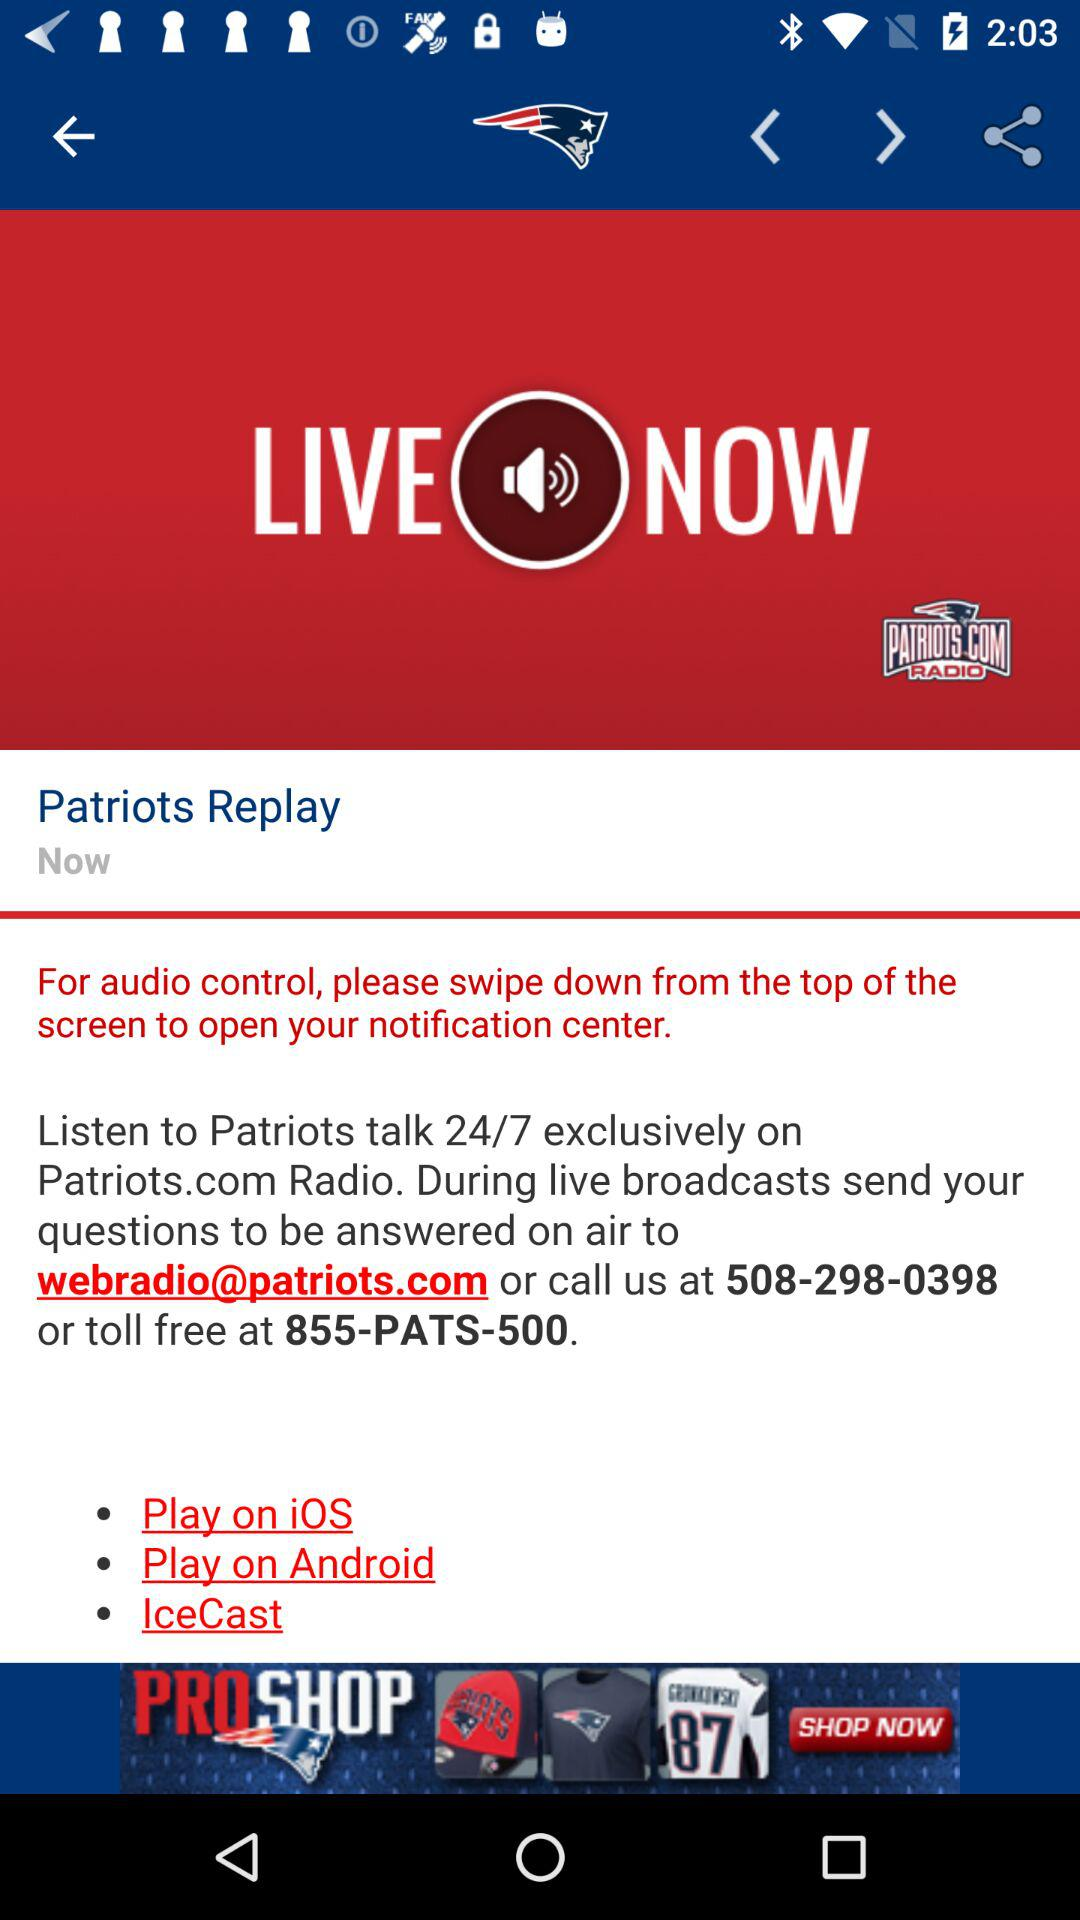What day is it?
When the provided information is insufficient, respond with <no answer>. <no answer> 